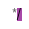Convert code to text. <code><loc_0><loc_0><loc_500><loc_500><_JavaScript_> */
</code> 